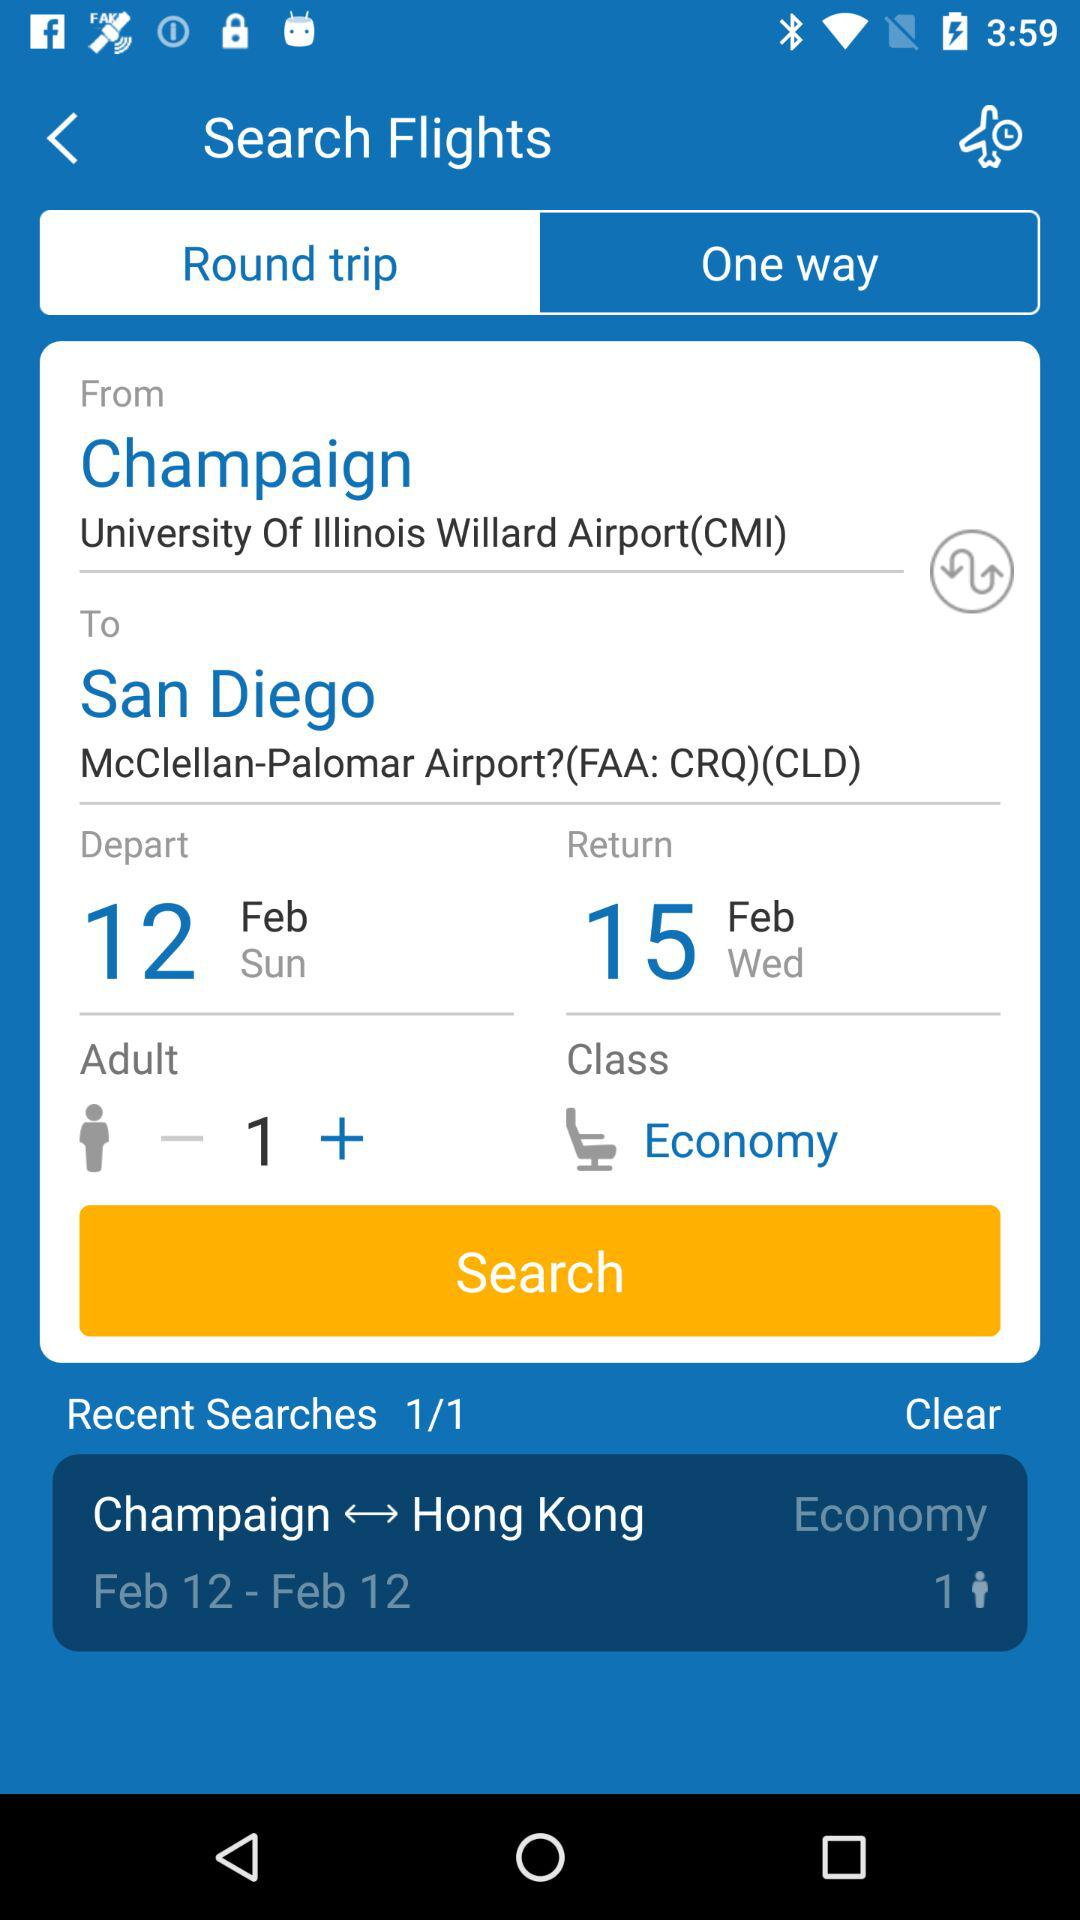How many more days are there between the departure date and the return date?
Answer the question using a single word or phrase. 3 